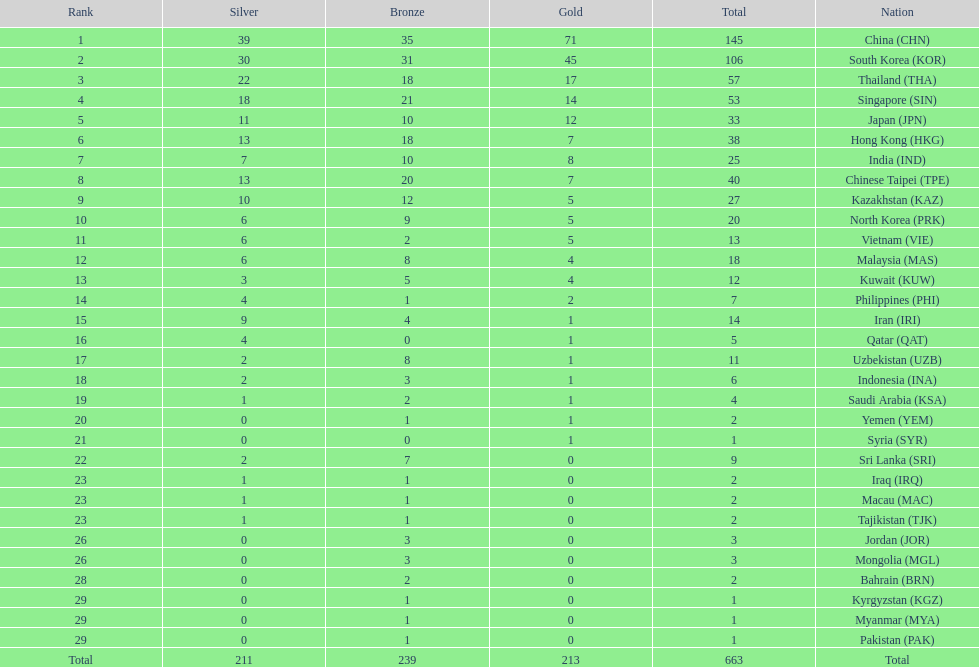What is the total number of medals that india won in the asian youth games? 25. 